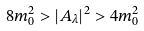Convert formula to latex. <formula><loc_0><loc_0><loc_500><loc_500>8 m _ { 0 } ^ { 2 } > | A _ { \lambda } | ^ { 2 } > 4 m _ { 0 } ^ { 2 }</formula> 